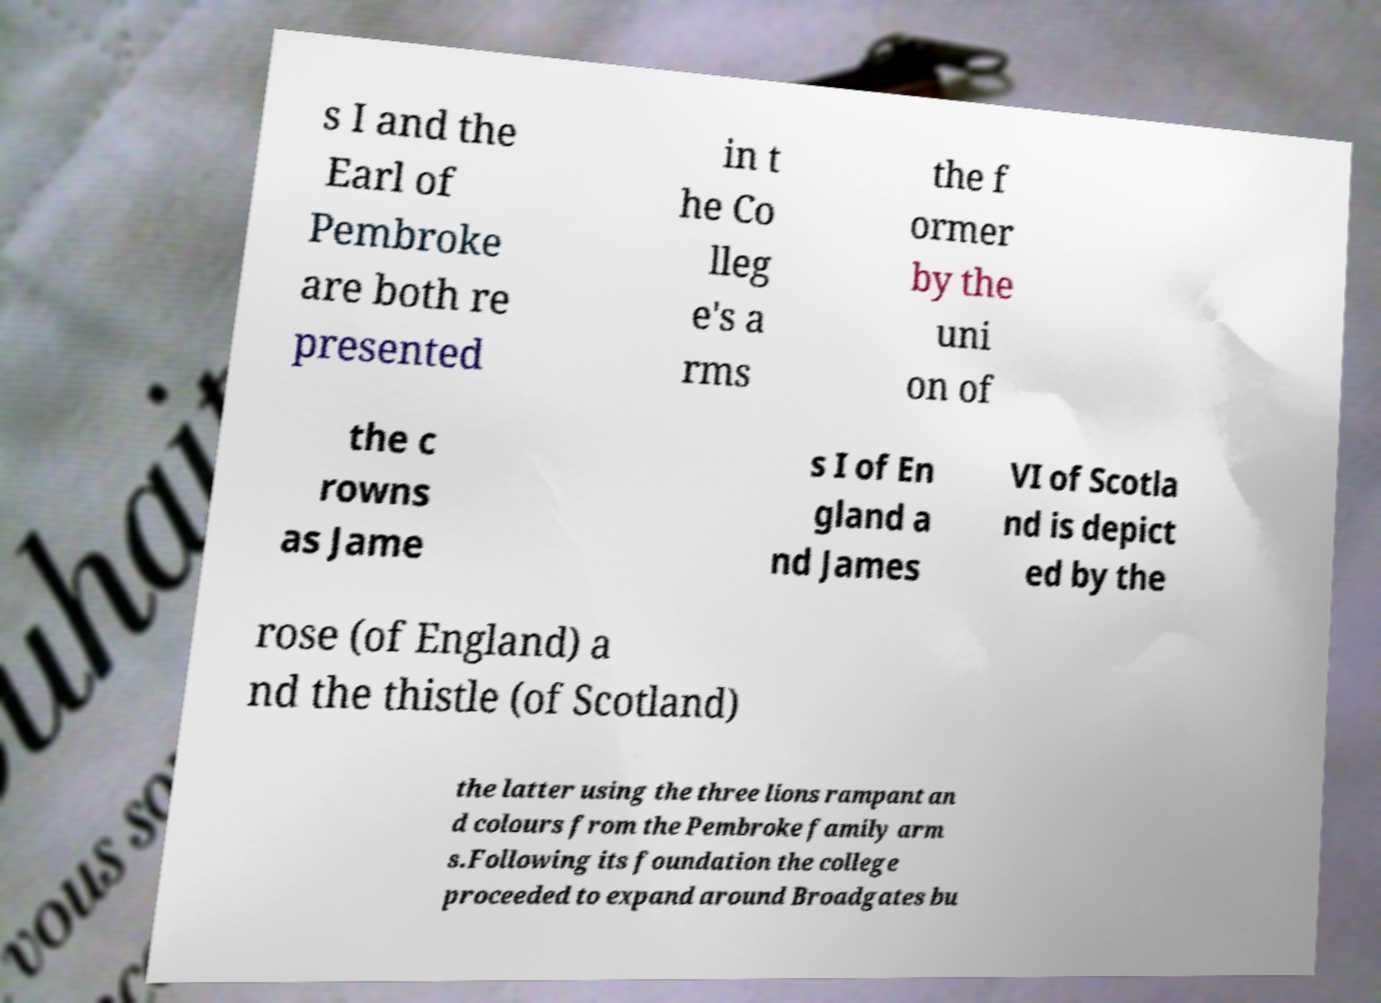Can you read and provide the text displayed in the image?This photo seems to have some interesting text. Can you extract and type it out for me? s I and the Earl of Pembroke are both re presented in t he Co lleg e's a rms the f ormer by the uni on of the c rowns as Jame s I of En gland a nd James VI of Scotla nd is depict ed by the rose (of England) a nd the thistle (of Scotland) the latter using the three lions rampant an d colours from the Pembroke family arm s.Following its foundation the college proceeded to expand around Broadgates bu 